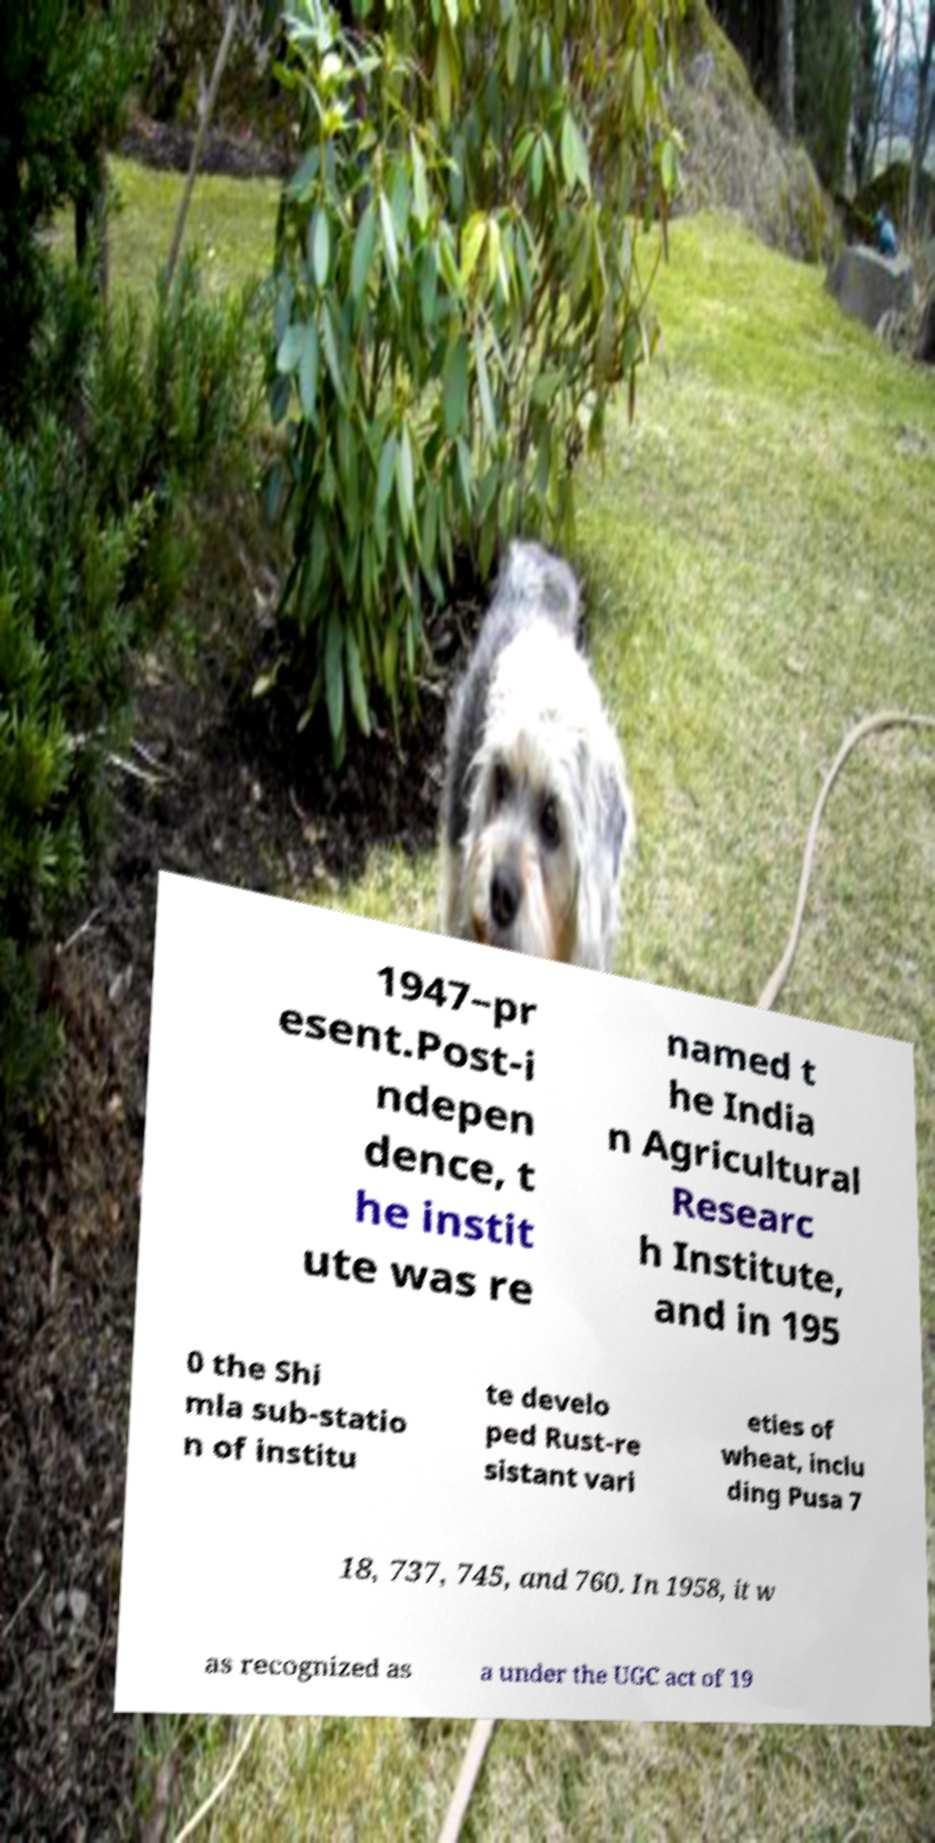Can you accurately transcribe the text from the provided image for me? 1947–pr esent.Post-i ndepen dence, t he instit ute was re named t he India n Agricultural Researc h Institute, and in 195 0 the Shi mla sub-statio n of institu te develo ped Rust-re sistant vari eties of wheat, inclu ding Pusa 7 18, 737, 745, and 760. In 1958, it w as recognized as a under the UGC act of 19 